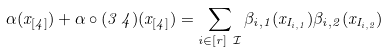<formula> <loc_0><loc_0><loc_500><loc_500>\alpha ( x _ { [ 4 ] } ) + \alpha \circ ( 3 \, 4 ) ( x _ { [ 4 ] } ) = \sum _ { i \in [ r ] \ \mathcal { I } } \beta _ { i , 1 } ( x _ { I _ { i , 1 } } ) \beta _ { i , 2 } ( x _ { I _ { i , 2 } } )</formula> 